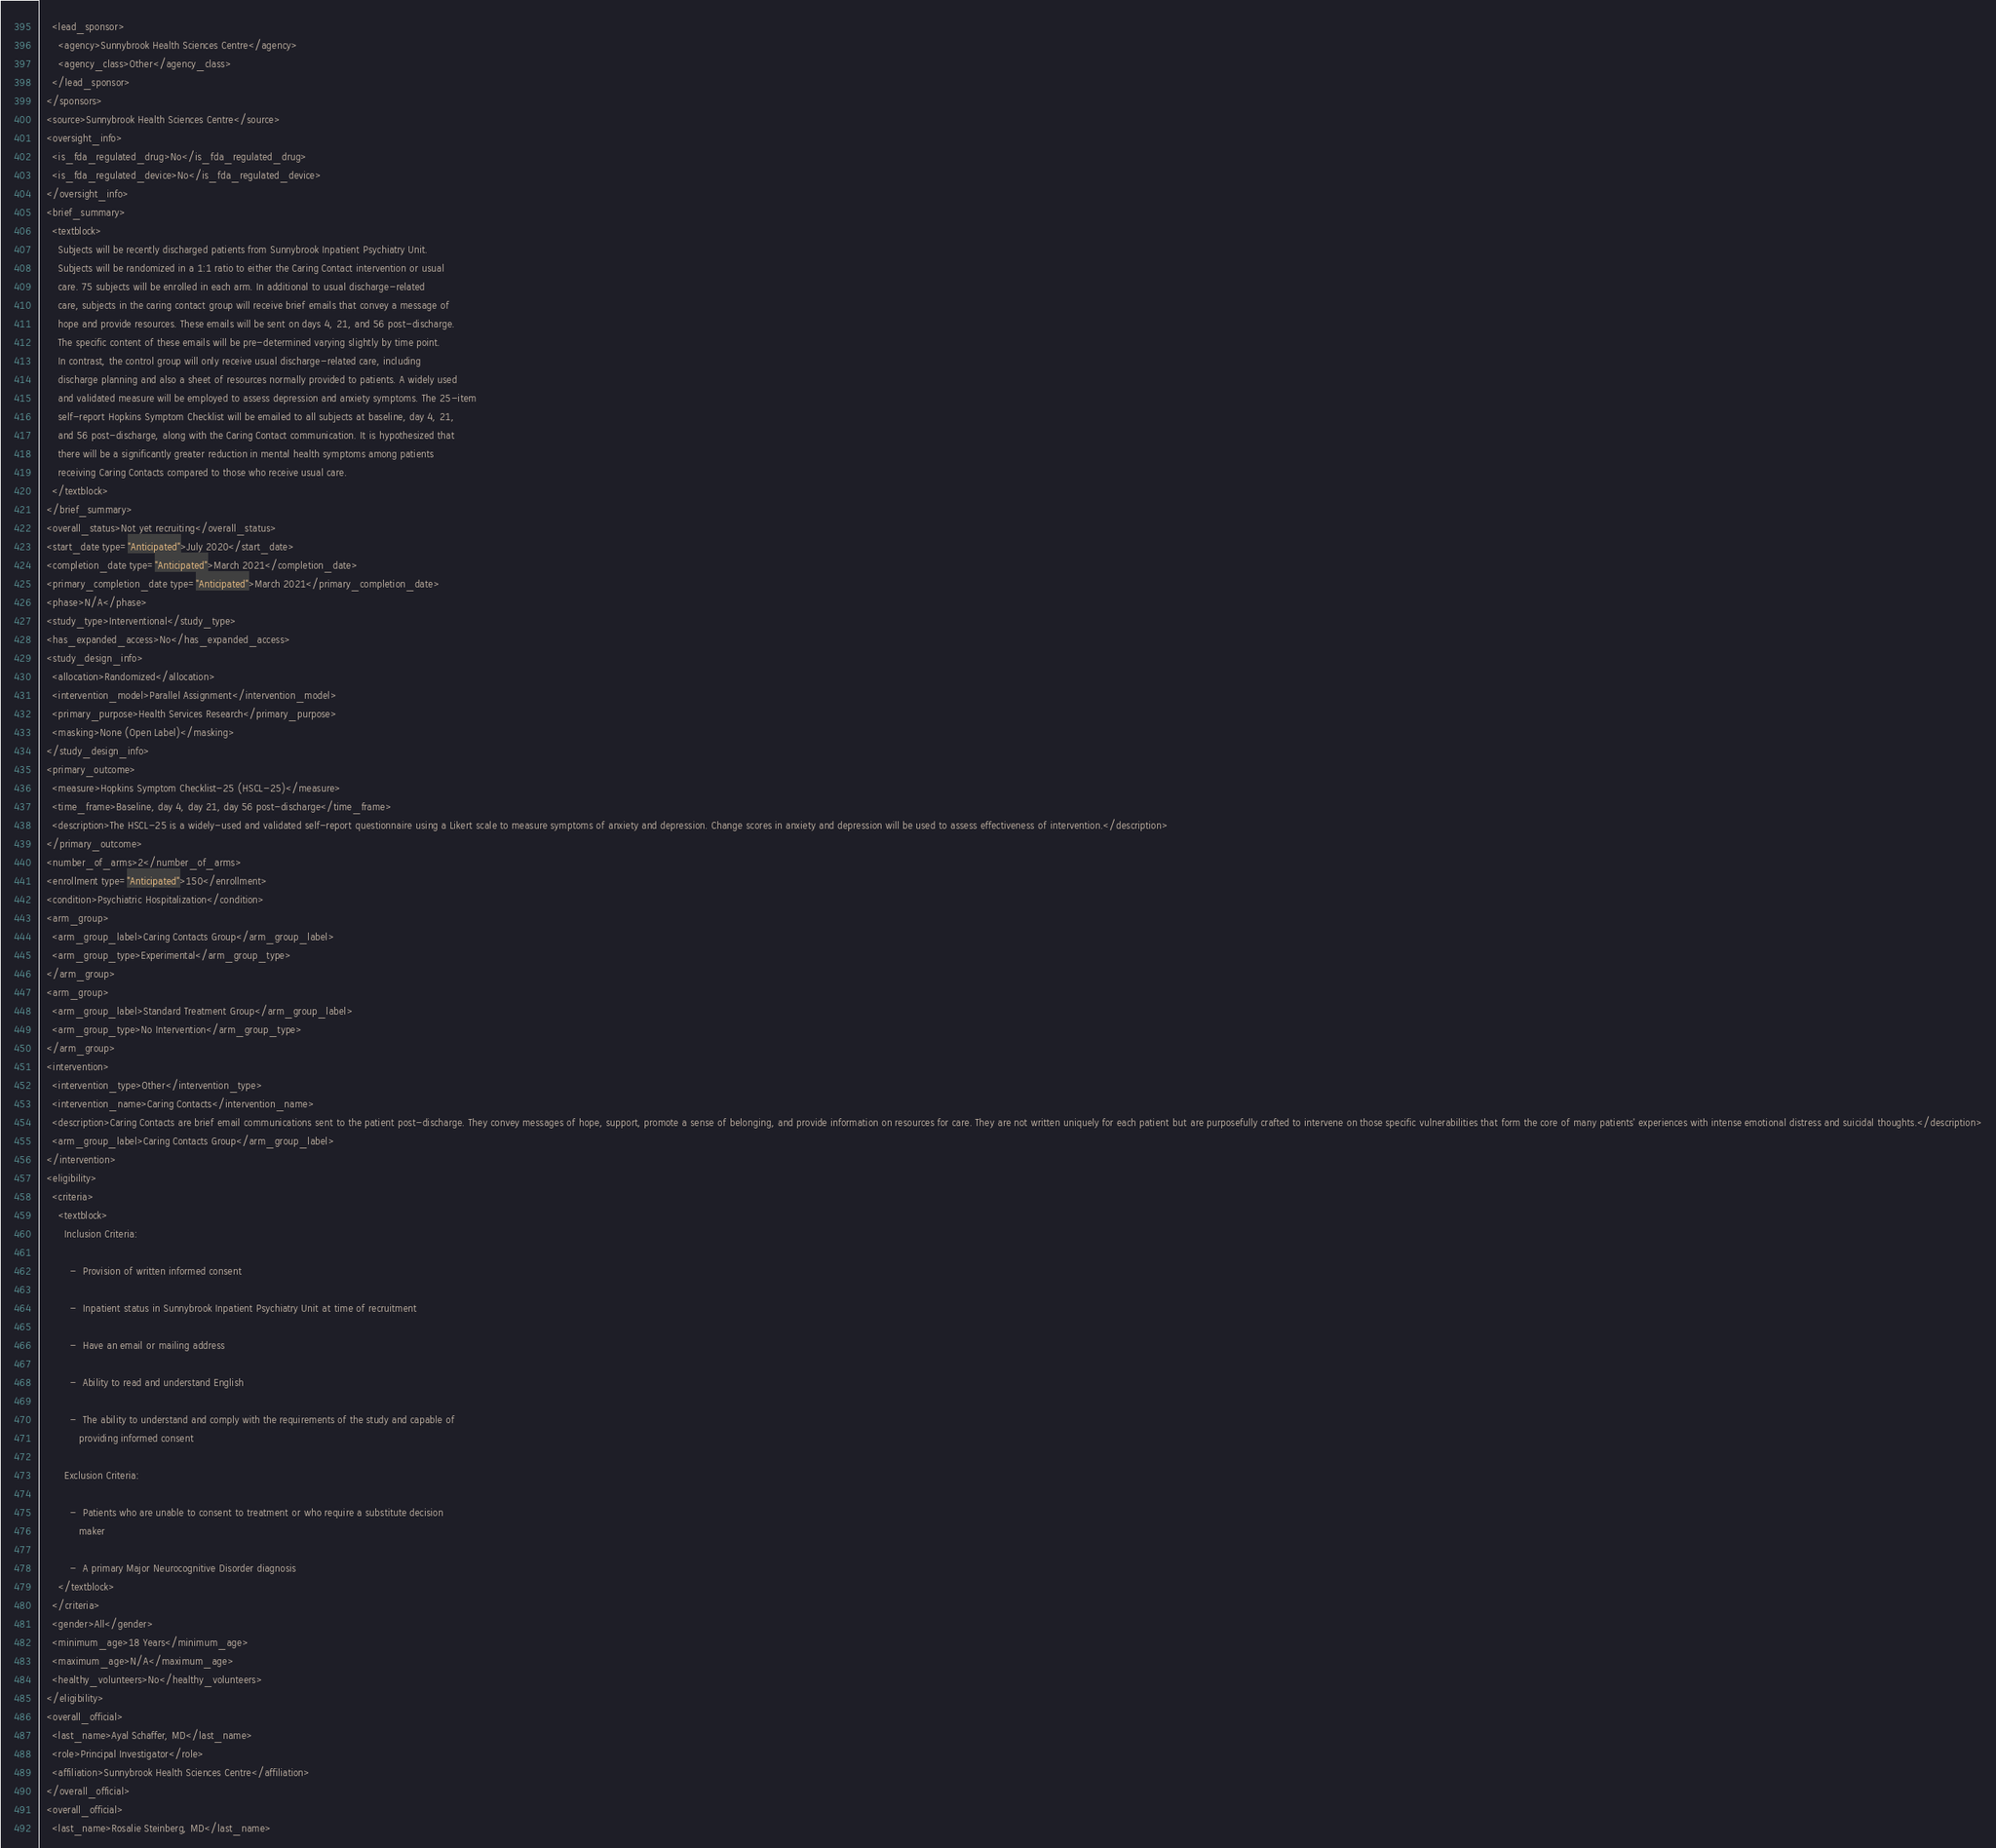<code> <loc_0><loc_0><loc_500><loc_500><_XML_>    <lead_sponsor>
      <agency>Sunnybrook Health Sciences Centre</agency>
      <agency_class>Other</agency_class>
    </lead_sponsor>
  </sponsors>
  <source>Sunnybrook Health Sciences Centre</source>
  <oversight_info>
    <is_fda_regulated_drug>No</is_fda_regulated_drug>
    <is_fda_regulated_device>No</is_fda_regulated_device>
  </oversight_info>
  <brief_summary>
    <textblock>
      Subjects will be recently discharged patients from Sunnybrook Inpatient Psychiatry Unit.
      Subjects will be randomized in a 1:1 ratio to either the Caring Contact intervention or usual
      care. 75 subjects will be enrolled in each arm. In additional to usual discharge-related
      care, subjects in the caring contact group will receive brief emails that convey a message of
      hope and provide resources. These emails will be sent on days 4, 21, and 56 post-discharge.
      The specific content of these emails will be pre-determined varying slightly by time point.
      In contrast, the control group will only receive usual discharge-related care, including
      discharge planning and also a sheet of resources normally provided to patients. A widely used
      and validated measure will be employed to assess depression and anxiety symptoms. The 25-item
      self-report Hopkins Symptom Checklist will be emailed to all subjects at baseline, day 4, 21,
      and 56 post-discharge, along with the Caring Contact communication. It is hypothesized that
      there will be a significantly greater reduction in mental health symptoms among patients
      receiving Caring Contacts compared to those who receive usual care.
    </textblock>
  </brief_summary>
  <overall_status>Not yet recruiting</overall_status>
  <start_date type="Anticipated">July 2020</start_date>
  <completion_date type="Anticipated">March 2021</completion_date>
  <primary_completion_date type="Anticipated">March 2021</primary_completion_date>
  <phase>N/A</phase>
  <study_type>Interventional</study_type>
  <has_expanded_access>No</has_expanded_access>
  <study_design_info>
    <allocation>Randomized</allocation>
    <intervention_model>Parallel Assignment</intervention_model>
    <primary_purpose>Health Services Research</primary_purpose>
    <masking>None (Open Label)</masking>
  </study_design_info>
  <primary_outcome>
    <measure>Hopkins Symptom Checklist-25 (HSCL-25)</measure>
    <time_frame>Baseline, day 4, day 21, day 56 post-discharge</time_frame>
    <description>The HSCL-25 is a widely-used and validated self-report questionnaire using a Likert scale to measure symptoms of anxiety and depression. Change scores in anxiety and depression will be used to assess effectiveness of intervention.</description>
  </primary_outcome>
  <number_of_arms>2</number_of_arms>
  <enrollment type="Anticipated">150</enrollment>
  <condition>Psychiatric Hospitalization</condition>
  <arm_group>
    <arm_group_label>Caring Contacts Group</arm_group_label>
    <arm_group_type>Experimental</arm_group_type>
  </arm_group>
  <arm_group>
    <arm_group_label>Standard Treatment Group</arm_group_label>
    <arm_group_type>No Intervention</arm_group_type>
  </arm_group>
  <intervention>
    <intervention_type>Other</intervention_type>
    <intervention_name>Caring Contacts</intervention_name>
    <description>Caring Contacts are brief email communications sent to the patient post-discharge. They convey messages of hope, support, promote a sense of belonging, and provide information on resources for care. They are not written uniquely for each patient but are purposefully crafted to intervene on those specific vulnerabilities that form the core of many patients' experiences with intense emotional distress and suicidal thoughts.</description>
    <arm_group_label>Caring Contacts Group</arm_group_label>
  </intervention>
  <eligibility>
    <criteria>
      <textblock>
        Inclusion Criteria:

          -  Provision of written informed consent

          -  Inpatient status in Sunnybrook Inpatient Psychiatry Unit at time of recruitment

          -  Have an email or mailing address

          -  Ability to read and understand English

          -  The ability to understand and comply with the requirements of the study and capable of
             providing informed consent

        Exclusion Criteria:

          -  Patients who are unable to consent to treatment or who require a substitute decision
             maker

          -  A primary Major Neurocognitive Disorder diagnosis
      </textblock>
    </criteria>
    <gender>All</gender>
    <minimum_age>18 Years</minimum_age>
    <maximum_age>N/A</maximum_age>
    <healthy_volunteers>No</healthy_volunteers>
  </eligibility>
  <overall_official>
    <last_name>Ayal Schaffer, MD</last_name>
    <role>Principal Investigator</role>
    <affiliation>Sunnybrook Health Sciences Centre</affiliation>
  </overall_official>
  <overall_official>
    <last_name>Rosalie Steinberg, MD</last_name></code> 